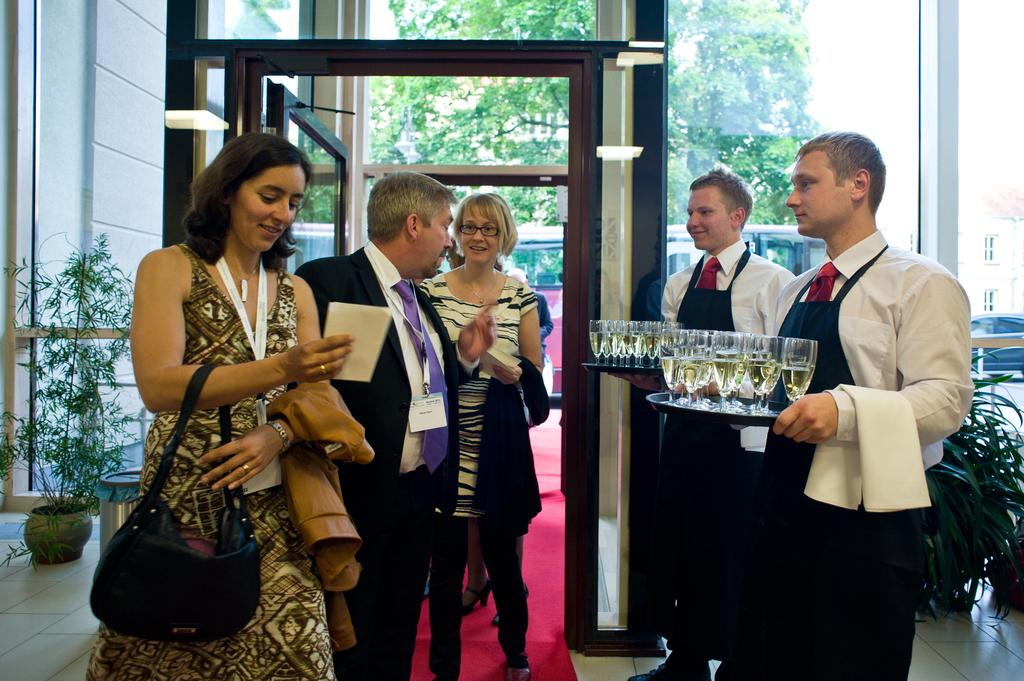What is happening in the image involving the group of people? There is a group of people standing in a building. Who else is present in the image besides the group of people? There are waiters beside the group of people. What are the waiters holding in the image? The waiters are holding trays with glasses of wine. What can be seen in the background of the image? There are trees visible in the background. What type of winter sport is being played in the image? There is no winter sport being played in the image; it features a group of people standing in a building with waiters holding trays of wine. How many cubs are visible in the image? There are no cubs present in the image. 